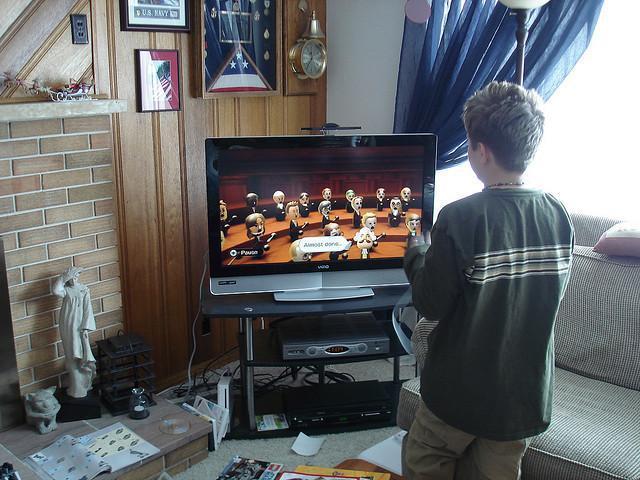How many people are watching?
Give a very brief answer. 1. How many tvs are there?
Give a very brief answer. 2. 